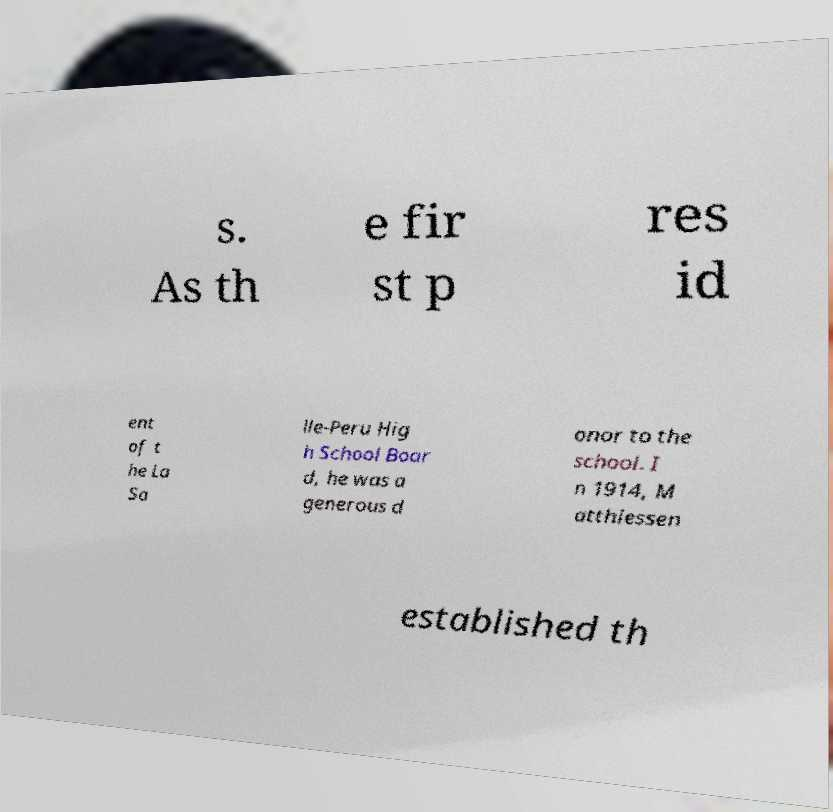Could you extract and type out the text from this image? s. As th e fir st p res id ent of t he La Sa lle-Peru Hig h School Boar d, he was a generous d onor to the school. I n 1914, M atthiessen established th 